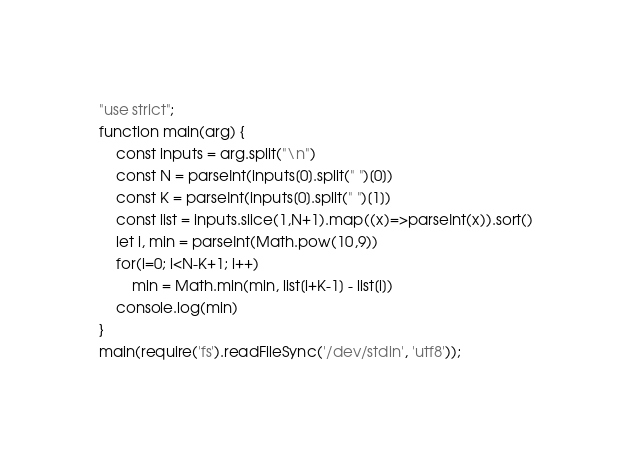<code> <loc_0><loc_0><loc_500><loc_500><_JavaScript_>"use strict";
function main(arg) {
    const inputs = arg.split("\n")
    const N = parseInt(inputs[0].split(" ")[0])
    const K = parseInt(inputs[0].split(" ")[1])
    const list = inputs.slice(1,N+1).map((x)=>parseInt(x)).sort()
    let i, min = parseInt(Math.pow(10,9))
    for(i=0; i<N-K+1; i++)
        min = Math.min(min, list[i+K-1] - list[i])
    console.log(min)
}
main(require('fs').readFileSync('/dev/stdin', 'utf8'));</code> 